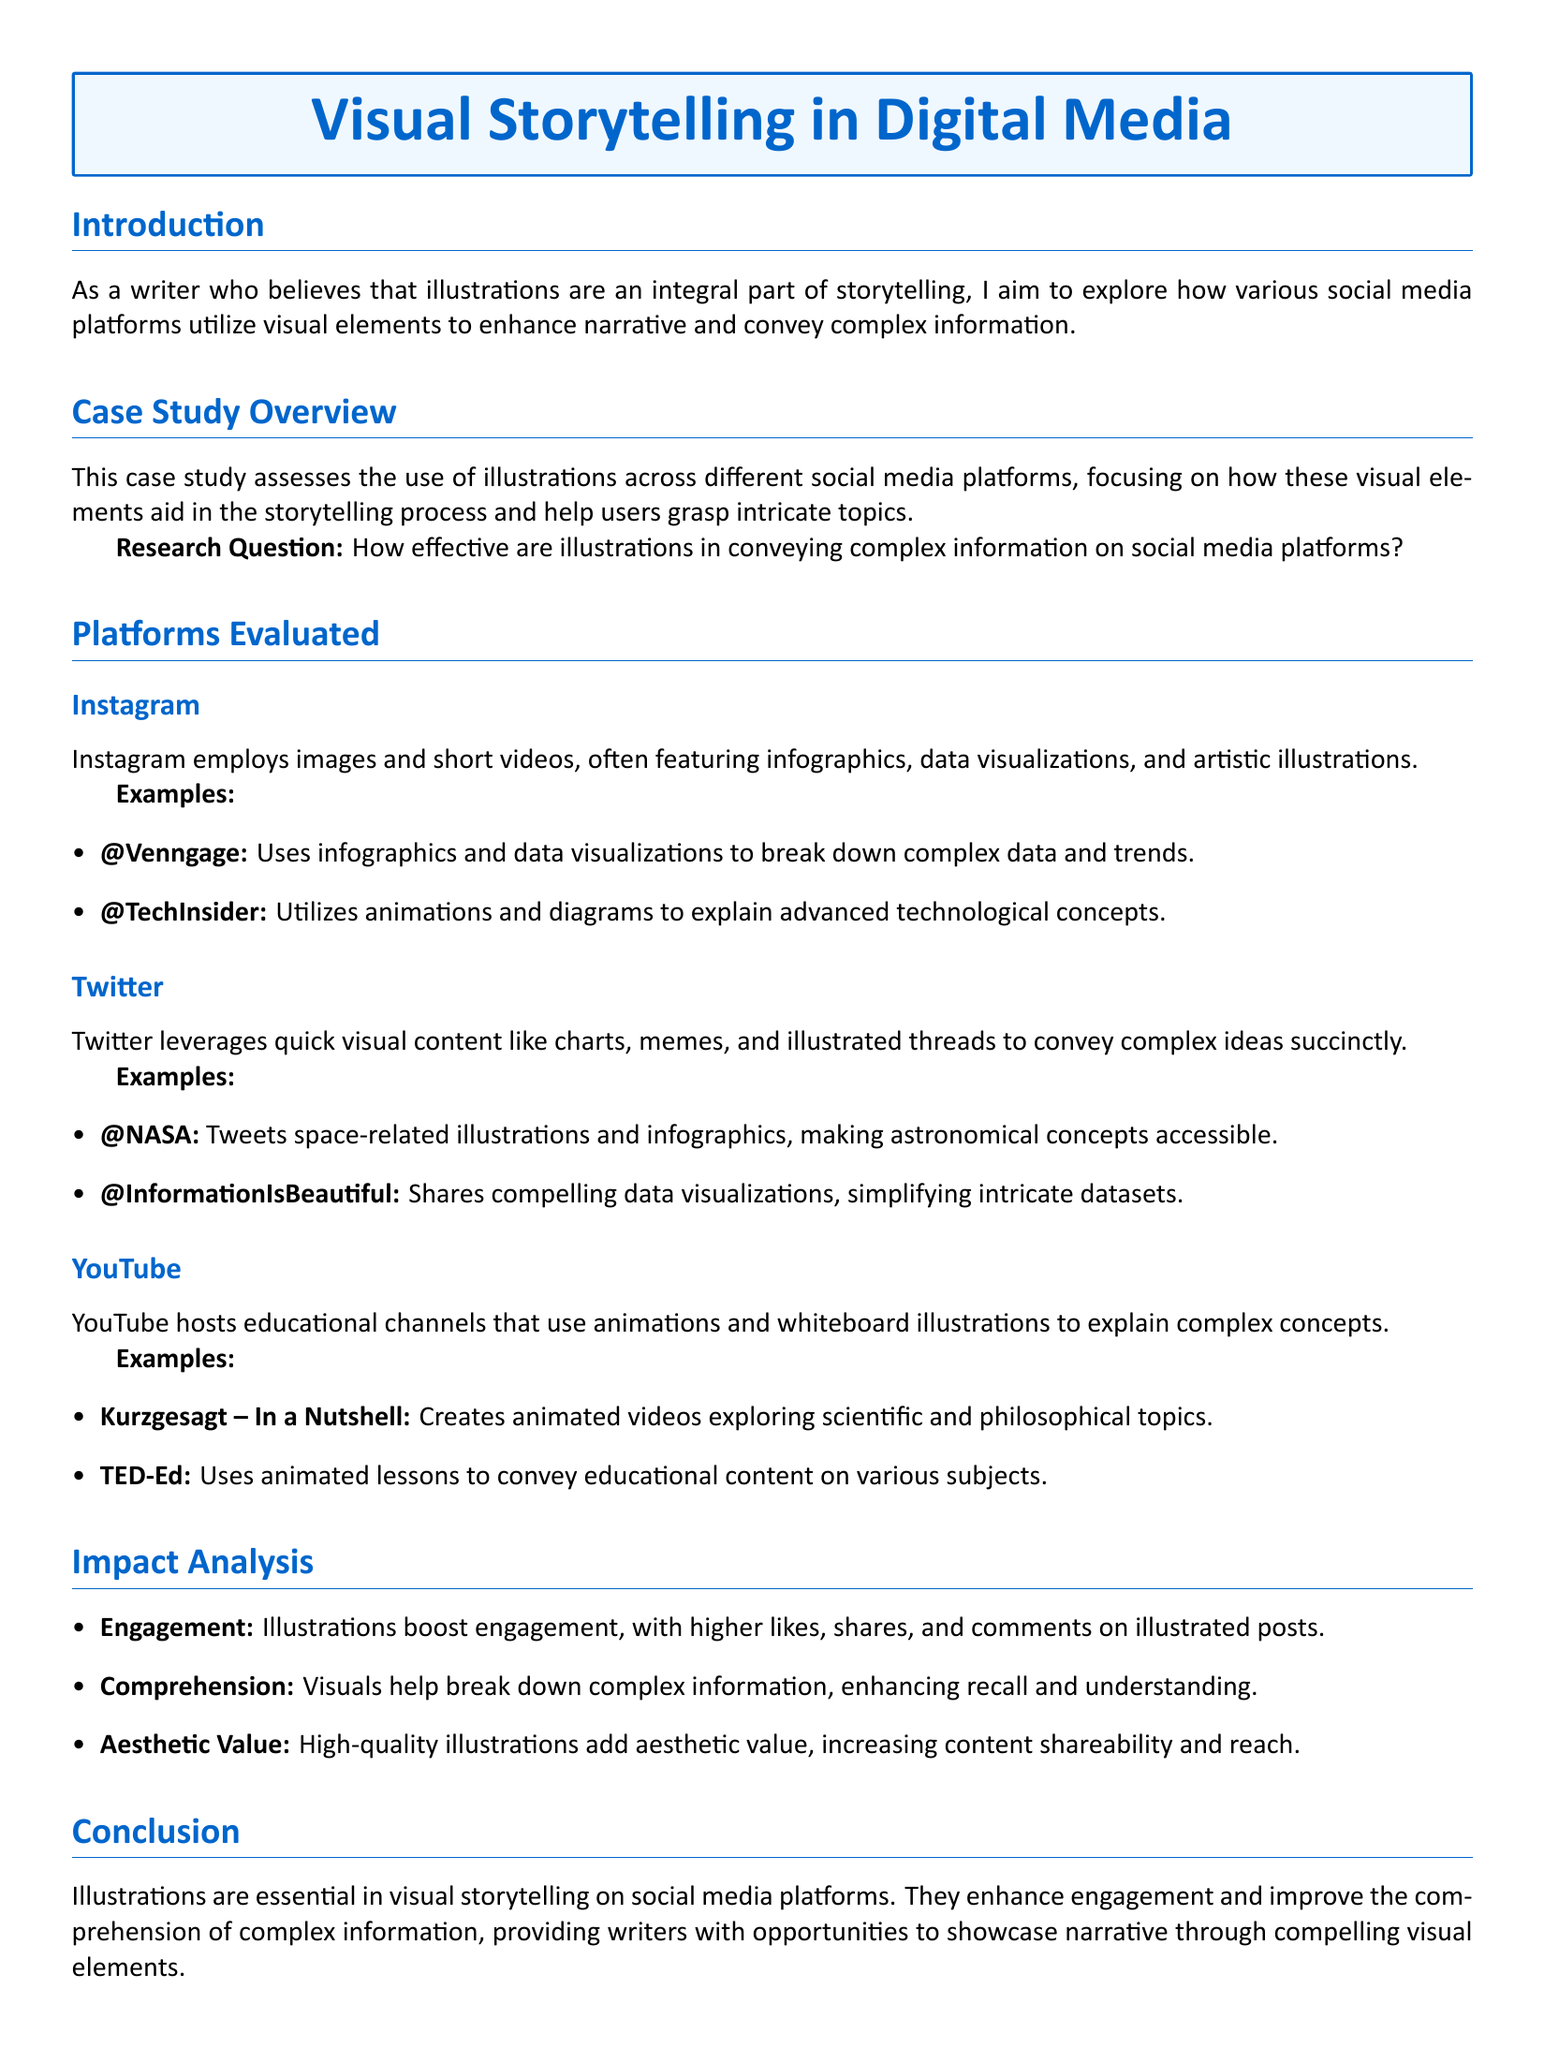What is the title of the case study? The title of the case study is provided in the document's title section.
Answer: Visual Storytelling in Digital Media Who uses infographics to break down complex data? The document provides examples of social media accounts using visual storytelling techniques.
Answer: @Venngage What type of content does Twitter leverage to convey ideas? The document states that Twitter uses specific forms of visual content.
Answer: charts Which YouTube channel creates animated videos exploring scientific topics? The document lists certain YouTube channels that utilize animations for educational purposes.
Answer: Kurzgesagt – In a Nutshell What is one impact of illustrations mentioned in the case study? The document summarizes the impacts of illustrations on social media engagement.
Answer: Engagement How do visuals assist in information comprehension? The case study evaluates the effectiveness of illustrations in conveying complex concepts.
Answer: enhance recall and understanding What are high-quality illustrations said to add to content? The document describes benefits of illustrations that enhance overall content quality.
Answer: aesthetic value What is the research question posed in the case study? The document outlines a primary inquiry to explore the role of visuals in social media.
Answer: How effective are illustrations in conveying complex information on social media platforms? What platform was noted for sharing space-related illustrations? The document provides specific examples of social media platforms and their unique content types.
Answer: Twitter What type of educational content does TED-Ed use? The document explains the types of visuals used in specific educational channels.
Answer: animated lessons 